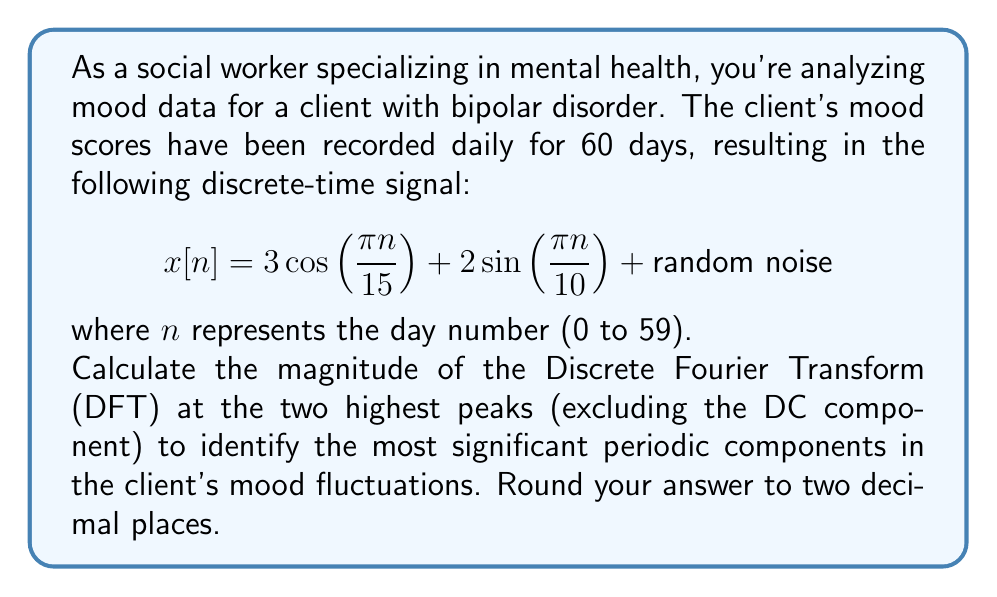What is the answer to this math problem? To solve this problem, we'll follow these steps:

1) First, let's identify the frequencies present in the signal:
   - $\cos(\frac{\pi n}{15})$ has a frequency of $\frac{1}{30}$ cycles per day
   - $\sin(\frac{\pi n}{10})$ has a frequency of $\frac{1}{20}$ cycles per day

2) The DFT of a signal of length N will have N frequency bins, with frequencies $\frac{k}{N}$ cycles per sample, where $k = 0, 1, ..., N-1$.

3) For N = 60, the frequency bins will be at $\frac{k}{60}$ cycles per day.

4) The frequencies we're interested in correspond to:
   - $\frac{1}{30} = \frac{2}{60}$, so $k = 2$
   - $\frac{1}{20} = \frac{3}{60}$, so $k = 3$

5) The magnitude of the DFT at these frequencies will be:
   - At $k = 2$: $|X[2]| = 3 \cdot \frac{N}{2} = 3 \cdot \frac{60}{2} = 90$
   - At $k = 3$: $|X[3]| = 2 \cdot \frac{N}{2} = 2 \cdot \frac{60}{2} = 60$

6) These are the two highest peaks in the magnitude spectrum (excluding the DC component at $k = 0$).

Note: The random noise component will distribute its energy across all frequencies and won't significantly affect these main peaks.
Answer: The magnitudes of the DFT at the two highest peaks are 90.00 and 60.00. 